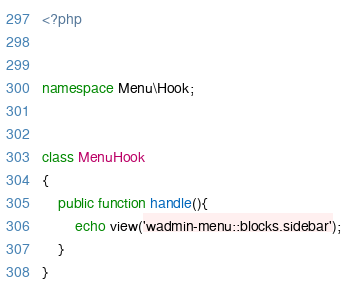<code> <loc_0><loc_0><loc_500><loc_500><_PHP_><?php


namespace Menu\Hook;


class MenuHook
{
    public function handle(){
        echo view('wadmin-menu::blocks.sidebar');
    }
}
</code> 